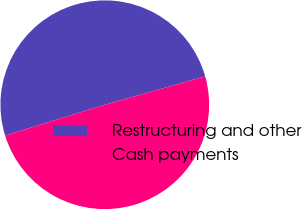Convert chart to OTSL. <chart><loc_0><loc_0><loc_500><loc_500><pie_chart><fcel>Restructuring and other<fcel>Cash payments<nl><fcel>50.38%<fcel>49.62%<nl></chart> 